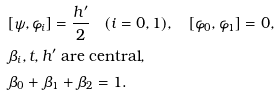Convert formula to latex. <formula><loc_0><loc_0><loc_500><loc_500>& [ \psi , \varphi _ { i } ] = \frac { h ^ { \prime } } { 2 } \quad ( i = 0 , 1 ) , \quad [ \varphi _ { 0 } , \varphi _ { 1 } ] = 0 , \\ & \text {$\beta_{i},t,h^{\prime}$ are central} , \\ & \beta _ { 0 } + \beta _ { 1 } + \beta _ { 2 } = 1 .</formula> 